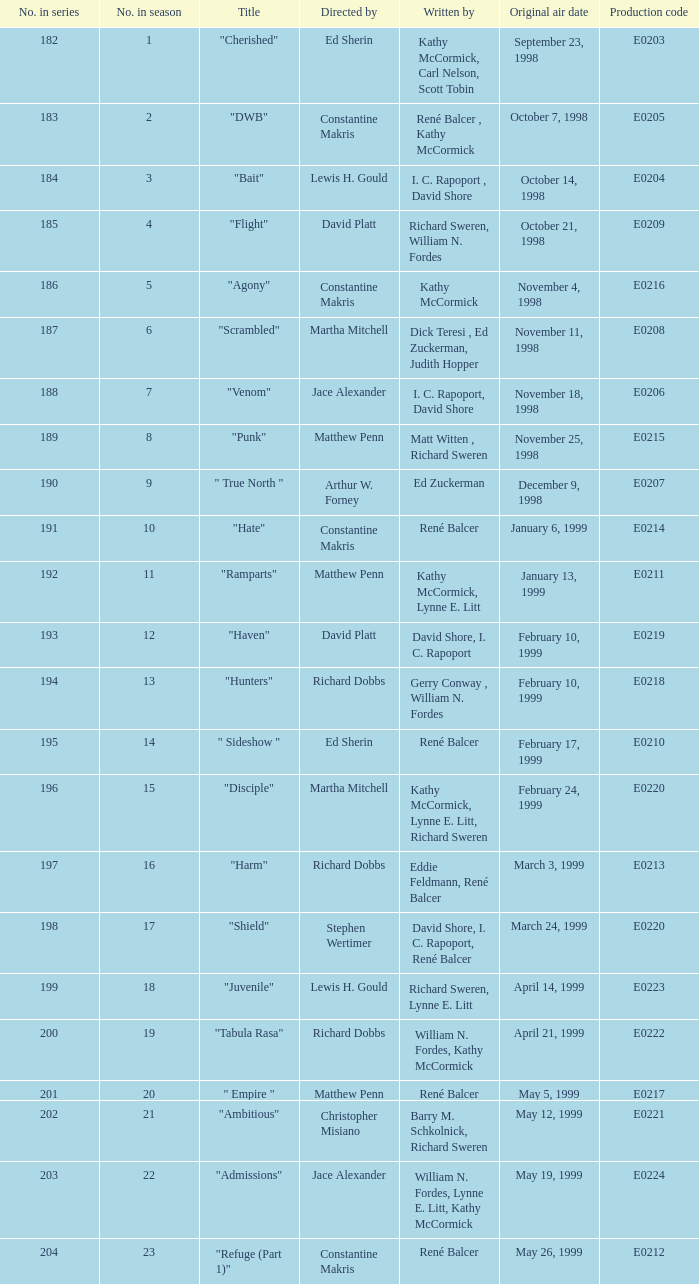On what date was the episode titled "bait" first broadcasted? October 14, 1998. 